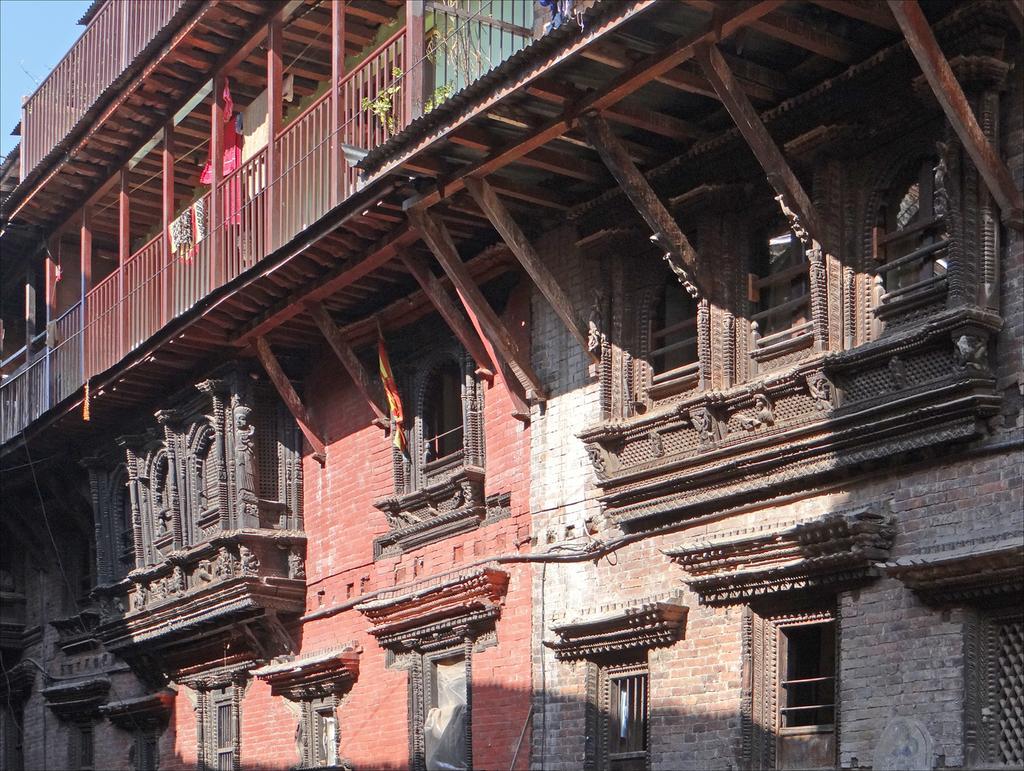How would you summarize this image in a sentence or two? In this image, I can see a building with windows, pillars, iron grilles and roofs. I can see clothes and a plant in the balcony. In the background, there is the sky. 